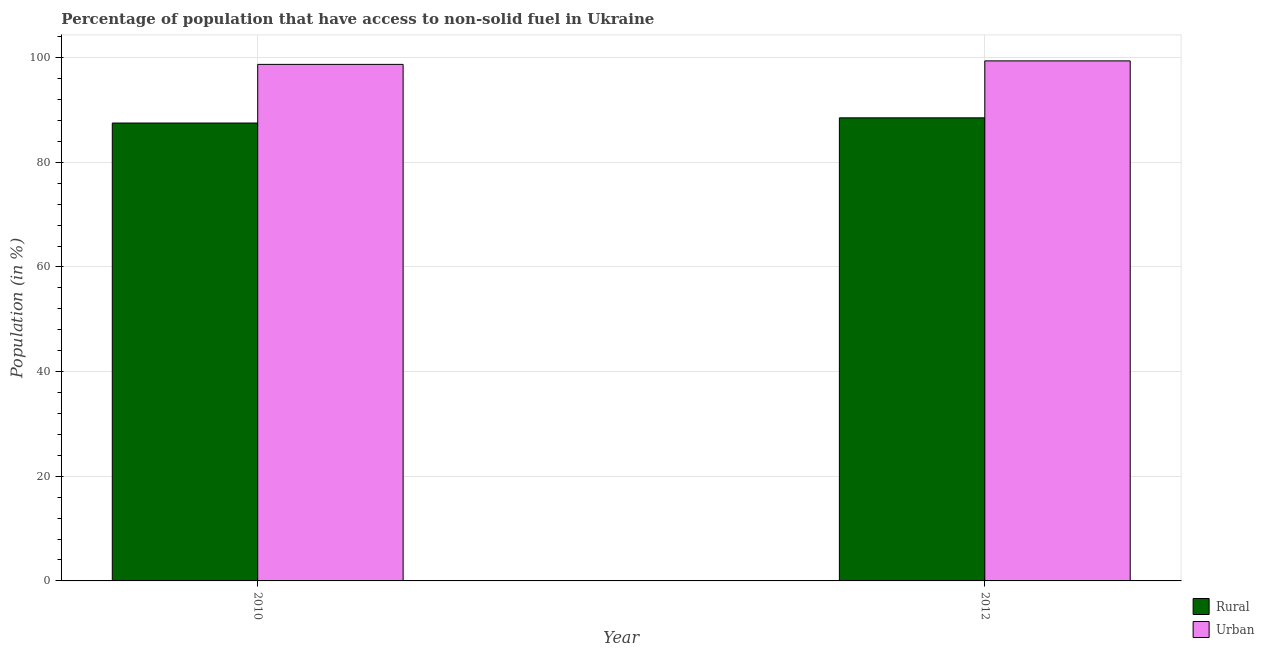How many different coloured bars are there?
Your response must be concise. 2. How many groups of bars are there?
Ensure brevity in your answer.  2. Are the number of bars per tick equal to the number of legend labels?
Keep it short and to the point. Yes. Are the number of bars on each tick of the X-axis equal?
Offer a very short reply. Yes. What is the label of the 1st group of bars from the left?
Make the answer very short. 2010. In how many cases, is the number of bars for a given year not equal to the number of legend labels?
Make the answer very short. 0. What is the urban population in 2012?
Offer a very short reply. 99.39. Across all years, what is the maximum urban population?
Ensure brevity in your answer.  99.39. Across all years, what is the minimum urban population?
Provide a succinct answer. 98.72. In which year was the urban population minimum?
Offer a terse response. 2010. What is the total rural population in the graph?
Make the answer very short. 176.01. What is the difference between the rural population in 2010 and that in 2012?
Your answer should be compact. -0.99. What is the difference between the rural population in 2012 and the urban population in 2010?
Offer a very short reply. 0.99. What is the average rural population per year?
Provide a succinct answer. 88.01. In how many years, is the urban population greater than 4 %?
Offer a very short reply. 2. What is the ratio of the urban population in 2010 to that in 2012?
Give a very brief answer. 0.99. What does the 2nd bar from the left in 2012 represents?
Give a very brief answer. Urban. What does the 1st bar from the right in 2010 represents?
Offer a terse response. Urban. How many bars are there?
Provide a short and direct response. 4. Where does the legend appear in the graph?
Offer a very short reply. Bottom right. How many legend labels are there?
Give a very brief answer. 2. How are the legend labels stacked?
Make the answer very short. Vertical. What is the title of the graph?
Your response must be concise. Percentage of population that have access to non-solid fuel in Ukraine. Does "Lower secondary rate" appear as one of the legend labels in the graph?
Give a very brief answer. No. What is the label or title of the X-axis?
Give a very brief answer. Year. What is the label or title of the Y-axis?
Your response must be concise. Population (in %). What is the Population (in %) of Rural in 2010?
Your answer should be very brief. 87.51. What is the Population (in %) in Urban in 2010?
Offer a terse response. 98.72. What is the Population (in %) in Rural in 2012?
Provide a short and direct response. 88.5. What is the Population (in %) in Urban in 2012?
Ensure brevity in your answer.  99.39. Across all years, what is the maximum Population (in %) of Rural?
Ensure brevity in your answer.  88.5. Across all years, what is the maximum Population (in %) of Urban?
Provide a short and direct response. 99.39. Across all years, what is the minimum Population (in %) of Rural?
Keep it short and to the point. 87.51. Across all years, what is the minimum Population (in %) of Urban?
Ensure brevity in your answer.  98.72. What is the total Population (in %) in Rural in the graph?
Your response must be concise. 176.01. What is the total Population (in %) in Urban in the graph?
Keep it short and to the point. 198.1. What is the difference between the Population (in %) in Rural in 2010 and that in 2012?
Provide a short and direct response. -0.99. What is the difference between the Population (in %) in Urban in 2010 and that in 2012?
Offer a terse response. -0.67. What is the difference between the Population (in %) in Rural in 2010 and the Population (in %) in Urban in 2012?
Offer a terse response. -11.88. What is the average Population (in %) of Rural per year?
Ensure brevity in your answer.  88.01. What is the average Population (in %) of Urban per year?
Keep it short and to the point. 99.05. In the year 2010, what is the difference between the Population (in %) in Rural and Population (in %) in Urban?
Your answer should be very brief. -11.21. In the year 2012, what is the difference between the Population (in %) of Rural and Population (in %) of Urban?
Offer a very short reply. -10.88. What is the ratio of the Population (in %) in Rural in 2010 to that in 2012?
Your answer should be very brief. 0.99. What is the ratio of the Population (in %) of Urban in 2010 to that in 2012?
Your answer should be compact. 0.99. What is the difference between the highest and the second highest Population (in %) of Rural?
Make the answer very short. 0.99. What is the difference between the highest and the second highest Population (in %) of Urban?
Provide a short and direct response. 0.67. What is the difference between the highest and the lowest Population (in %) in Urban?
Your answer should be very brief. 0.67. 